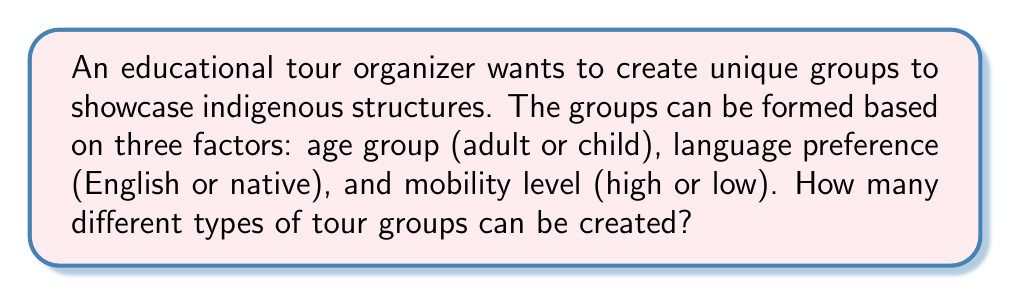Solve this math problem. Let's approach this step-by-step using the multiplication principle of combinatorics:

1) We have three independent factors to consider:
   - Age group: 2 options (adult or child)
   - Language preference: 2 options (English or native)
   - Mobility level: 2 options (high or low)

2) For each factor, we need to choose one option. The number of ways to make these choices can be multiplied together to get the total number of possible combinations.

3) Mathematically, this can be expressed as:

   $$ \text{Total combinations} = \text{Age options} \times \text{Language options} \times \text{Mobility options} $$

4) Substituting the numbers:

   $$ \text{Total combinations} = 2 \times 2 \times 2 $$

5) Calculating:

   $$ \text{Total combinations} = 8 $$

Therefore, the tour organizer can create 8 different types of tour groups based on these demographic factors.
Answer: 8 